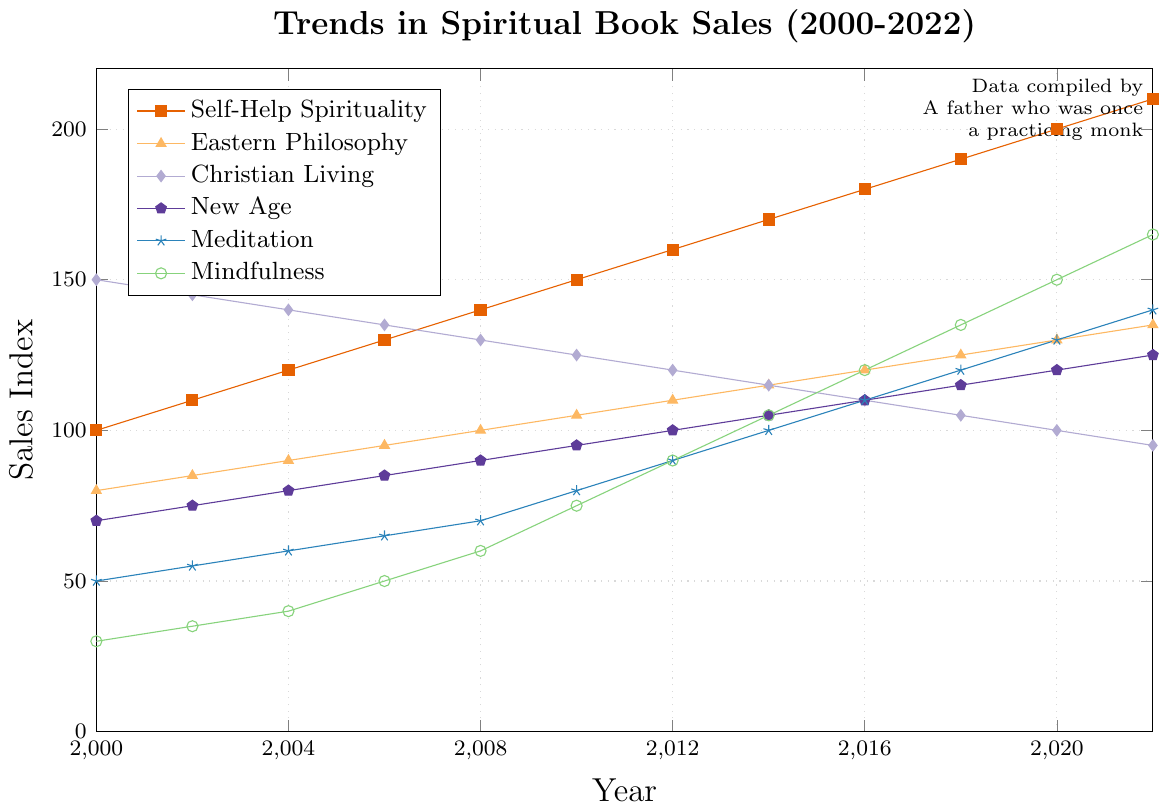What is the overall trend for Self-Help Spirituality books sales from 2000 to 2022? The figures show a consistent upward trend in the sales index for Self-Help Spirituality books. The sales increased from 100 in 2000 to 210 in 2022.
Answer: Upward trend Which genre had the highest sales index in 2000 and what was the value? By looking at the sales values for 2000, Christian Living has the highest sales index at 150.
Answer: Christian Living, 150 How do the sales of Mindfulness books in 2016 compare to the sales of Meditation books in the same year? In 2016, the sales index for Mindfulness is 120 while for Meditation it is also 110. Mindfulness books had higher sales.
Answer: Mindfulness books had higher sales; 120 vs 110 By how much did the sales of Christian Living books decline from 2002 to 2022? The sales index for Christian Living books decreased from 145 in 2002 to 95 in 2022. The decline in sales is 145 - 95 = 50.
Answer: 50 In what year did the Meditation book sales reach 100 in the sales index? By examining the sales index for Meditation, the index reaches 100 in the year 2014.
Answer: 2014 What was the average sales index for Self-Help Spirituality books between 2018 and 2022? To find the average, we add the sales indices from 2018 to 2022 and divide by the number of years: (190 + 200 + 210)/3 = 200.
Answer: 200 